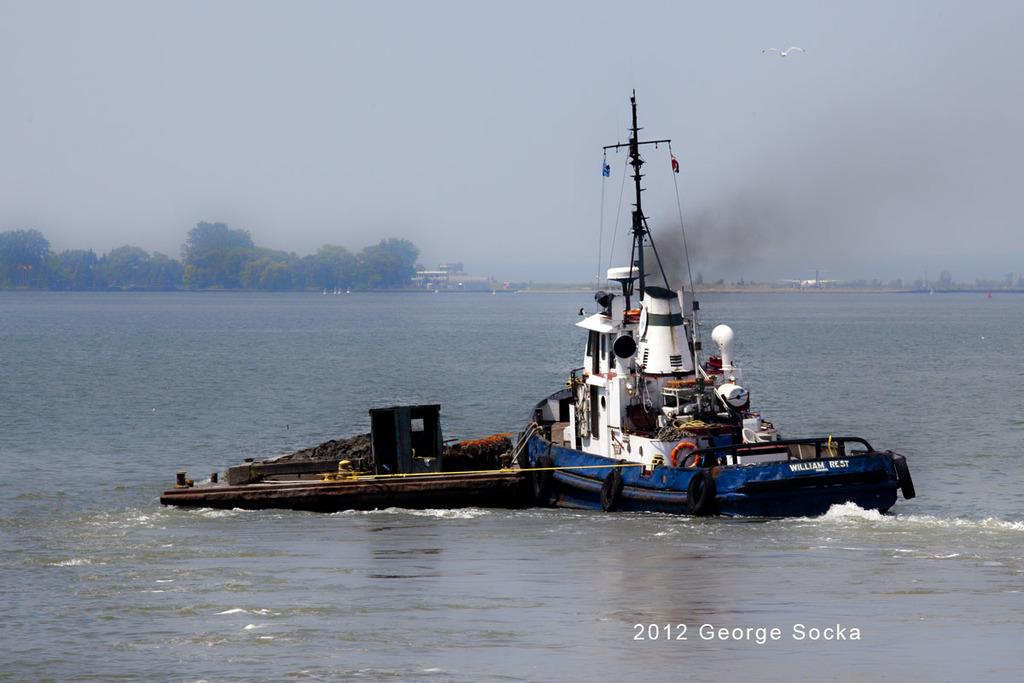What is the main subject of the image? There is a boat in the image. What can be seen on the boat? There are objects on the boat. What is visible in the background of the image? Trees, poles, and water are visible in the background. Can you describe the bird in the image? A bird is flying in the air. What is the color of the sky in the image? The sky is blue and white in color. How many chairs are placed on the boat in the image? There is no mention of chairs in the image; only objects are mentioned. Can you tell me how many pears are hanging from the trees in the background? There are no pears visible in the image; only trees are mentioned in the background. 